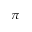<formula> <loc_0><loc_0><loc_500><loc_500>\pi</formula> 